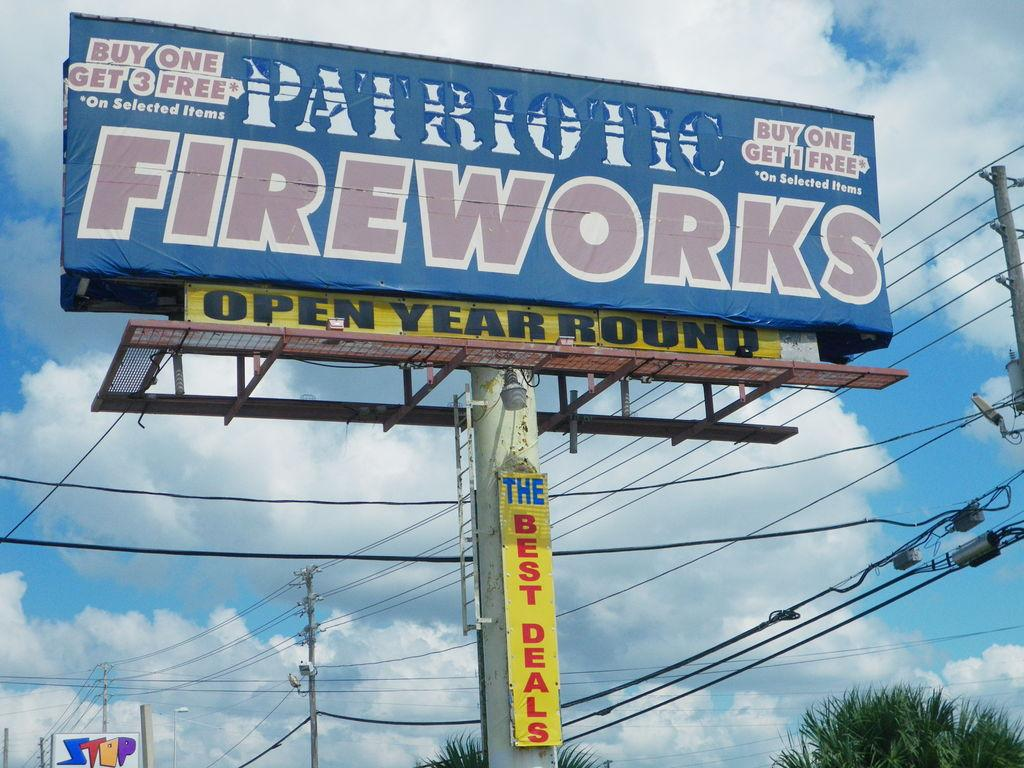<image>
Relay a brief, clear account of the picture shown. A place that sells fireworks is open year round. 